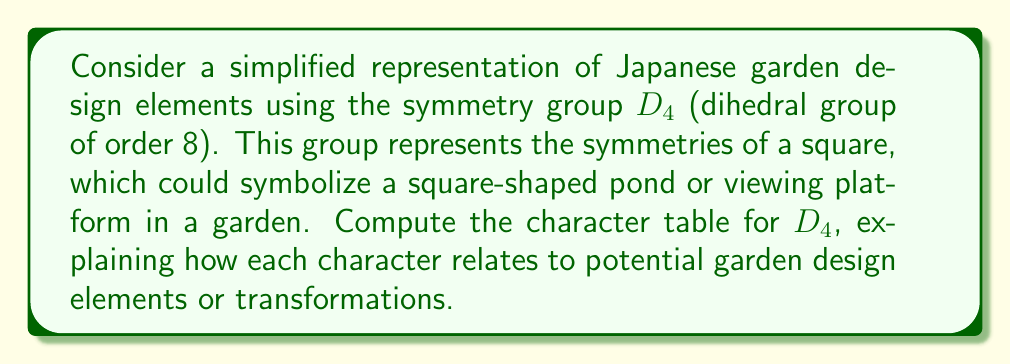Show me your answer to this math problem. To compute the character table for $D_4$, we'll follow these steps:

1) First, identify the conjugacy classes of $D_4$:
   - $\{e\}$ (identity)
   - $\{r^2\}$ (180° rotation)
   - $\{r, r^3\}$ (90° and 270° rotations)
   - $\{s, sr^2\}$ (reflections across diagonals)
   - $\{sr, sr^3\}$ (reflections across vertical and horizontal axes)

   These transformations could represent various ways of viewing or arranging garden elements.

2) Determine the number of irreducible representations:
   Number of irreducible representations = Number of conjugacy classes = 5

3) The dimensions of these representations must satisfy:
   $1^2 + 1^2 + 1^2 + 1^2 + 2^2 = 8$ (order of the group)

4) We know that there are four 1-dimensional representations and one 2-dimensional representation.

5) For the 1-dimensional representations:
   - The trivial representation: $\chi_1(g) = 1$ for all $g \in D_4$
   - $\chi_2(g) = 1$ for rotations, $-1$ for reflections
   - $\chi_3(g) = 1$ for $e$ and $r^2$, $-1$ for others
   - $\chi_4(g) = 1$ for $e$ and $r^2$, $-1$ for $r$ and $r^3$, $1$ for reflections

6) For the 2-dimensional representation $\chi_5$:
   - $\chi_5(e) = 2$
   - $\chi_5(r^2) = -2$
   - $\chi_5(r) = \chi_5(r^3) = 0$
   - $\chi_5(s) = \chi_5(sr^2) = 0$
   - $\chi_5(sr) = \chi_5(sr^3) = 0$

7) Construct the character table:

$$
\begin{array}{c|ccccc}
D_4 & \{e\} & \{r^2\} & \{r,r^3\} & \{s,sr^2\} & \{sr,sr^3\} \\
\hline
\chi_1 & 1 & 1 & 1 & 1 & 1 \\
\chi_2 & 1 & 1 & 1 & -1 & -1 \\
\chi_3 & 1 & 1 & -1 & 1 & -1 \\
\chi_4 & 1 & 1 & -1 & -1 & 1 \\
\chi_5 & 2 & -2 & 0 & 0 & 0
\end{array}
$$

In the context of garden design:
- $\chi_1$ represents overall symmetry preservation
- $\chi_2$ distinguishes between rotations and reflections
- $\chi_3$ and $\chi_4$ represent more nuanced symmetries
- $\chi_5$ captures the full 2-dimensional transformations of garden elements
Answer: $$
\begin{array}{c|ccccc}
D_4 & \{e\} & \{r^2\} & \{r,r^3\} & \{s,sr^2\} & \{sr,sr^3\} \\
\hline
\chi_1 & 1 & 1 & 1 & 1 & 1 \\
\chi_2 & 1 & 1 & 1 & -1 & -1 \\
\chi_3 & 1 & 1 & -1 & 1 & -1 \\
\chi_4 & 1 & 1 & -1 & -1 & 1 \\
\chi_5 & 2 & -2 & 0 & 0 & 0
\end{array}
$$ 